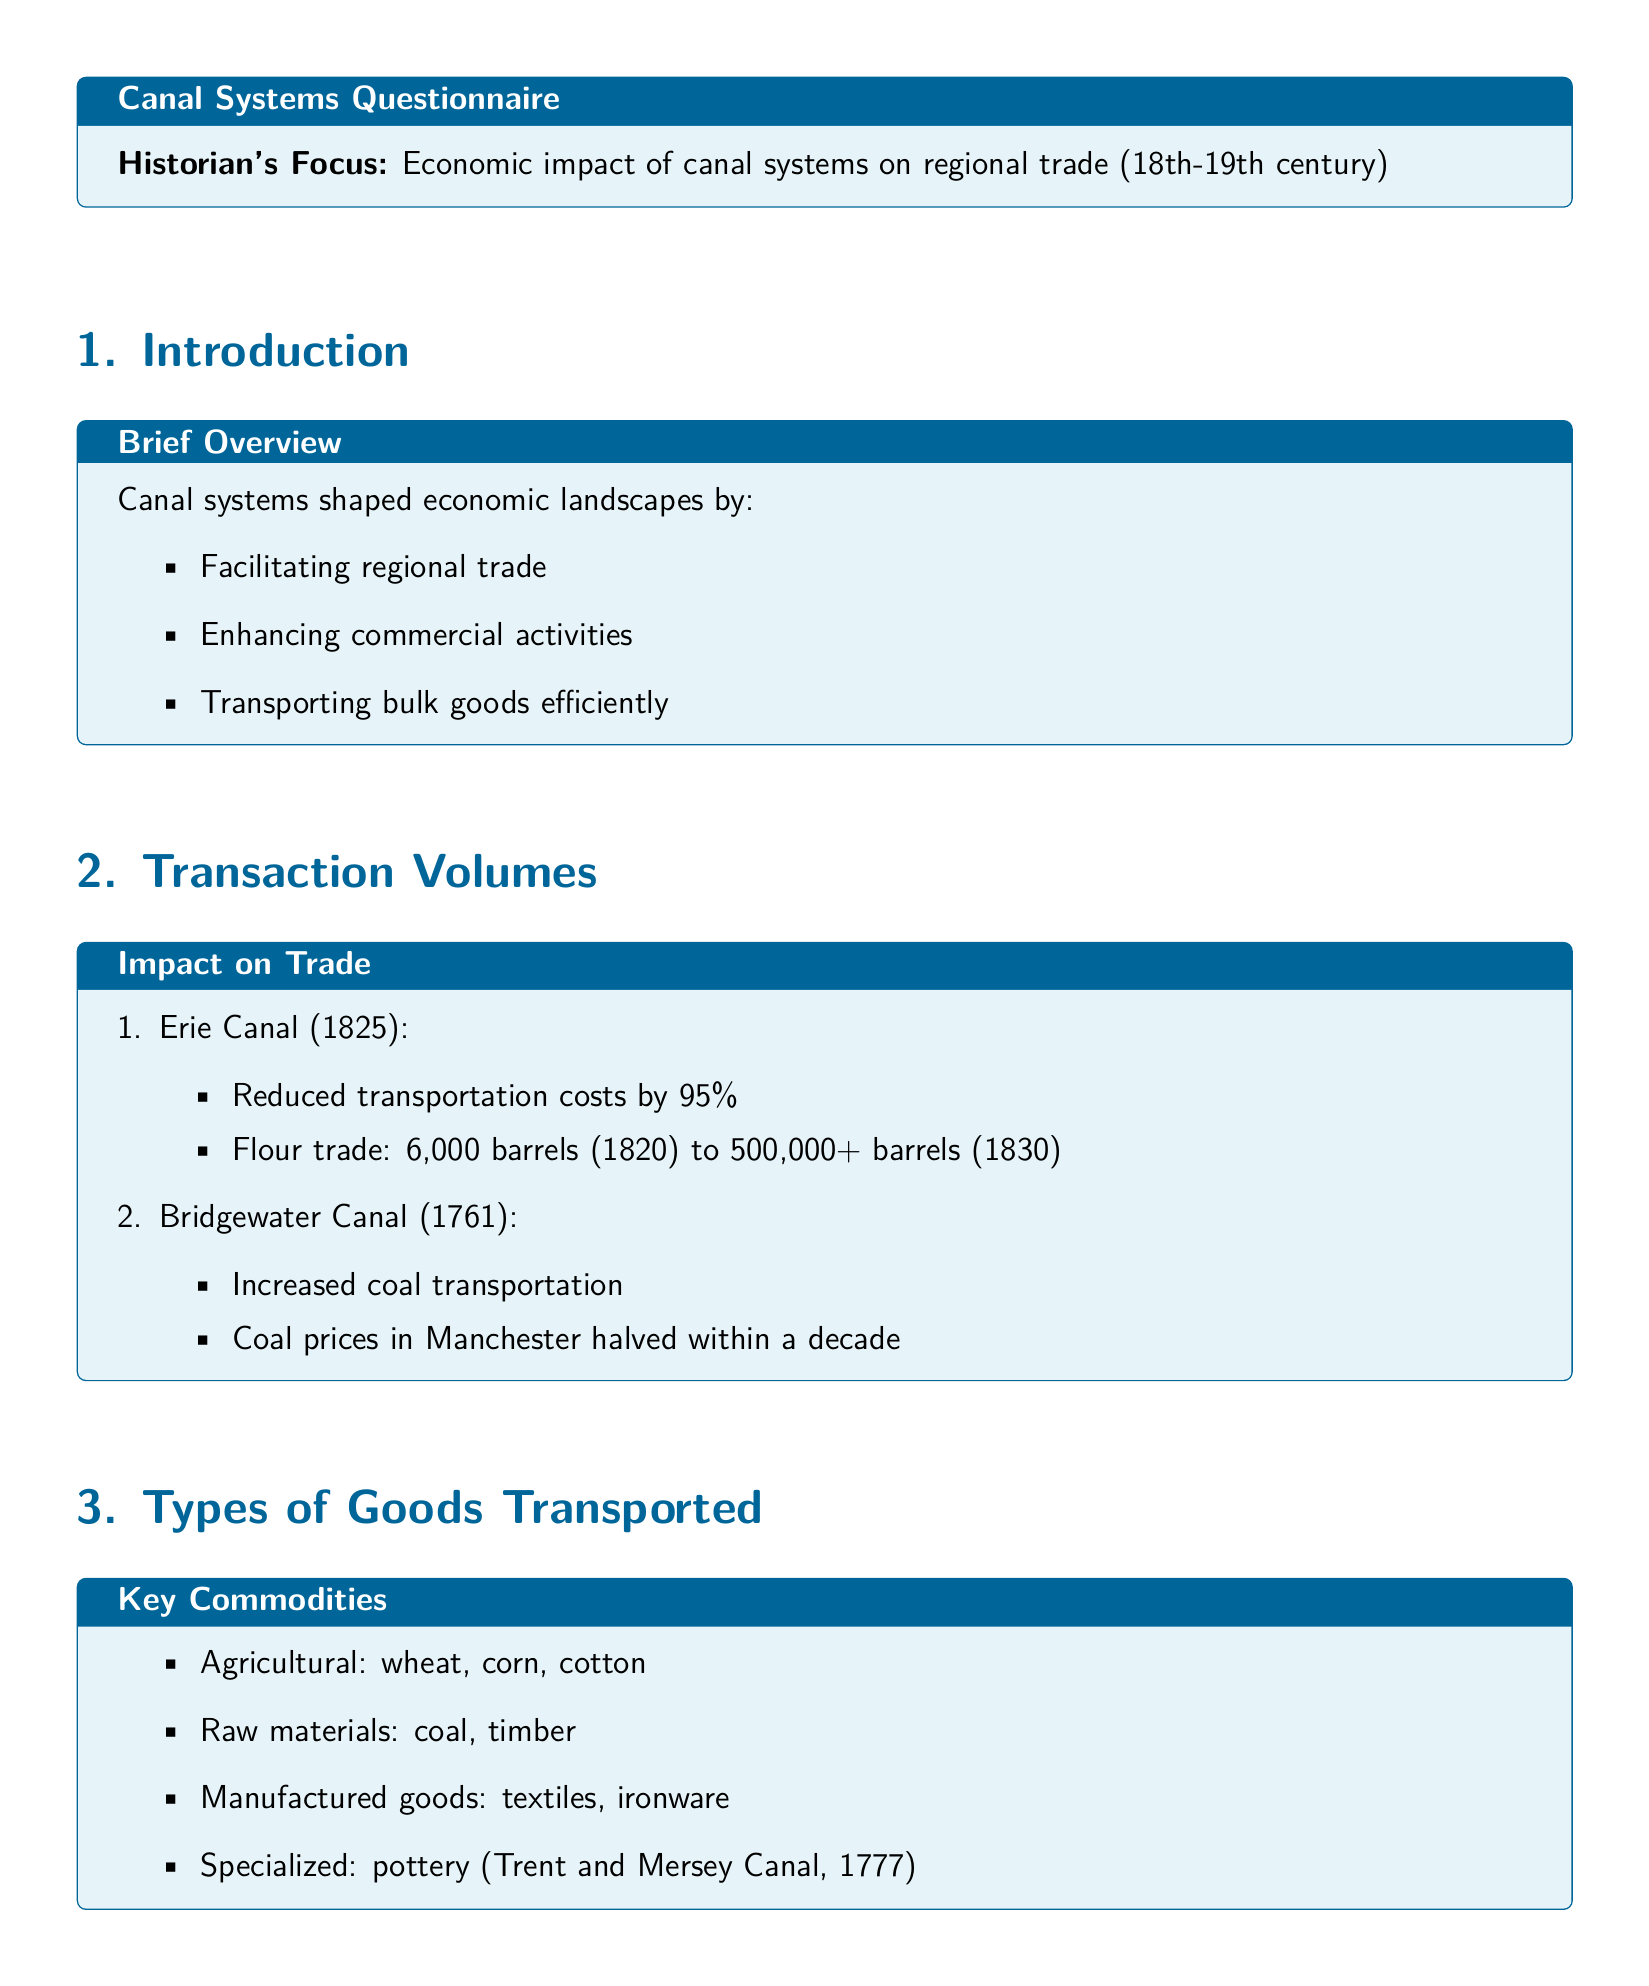What year was the Erie Canal completed? The document states that the Erie Canal was completed in 1825.
Answer: 1825 How much did transportation costs reduce by with the Erie Canal? The document indicates that transportation costs were reduced by 95% with the Erie Canal.
Answer: 95% What was the flour trade volume in barrels in 1830 after the Erie Canal's completion? The document mentions that the flour trade volume increased to over 500,000 barrels in 1830.
Answer: 500,000+ What types of agricultural goods were transported via canals? According to the document, the agricultural goods included wheat, corn, and cotton.
Answer: wheat, corn, cotton What key improvement did the Leeds and Liverpool Canal provide for goods transport? The document specifies that the Leeds and Liverpool Canal reduced goods transport time from weeks to days.
Answer: weeks to days Which canal was known for pottery transportation? The document states that the Trent and Mersey Canal, established in 1777, was known for pottery transportation.
Answer: Trent and Mersey Canal What economic effect did canal systems have on GDP? The document asserts that canal systems contributed to GDP growth as one of their outcomes.
Answer: GDP growth Which canal significantly halved coal prices in Manchester? The document indicates that the Bridgewater Canal was responsible for halving coal prices in Manchester.
Answer: Bridgewater Canal What was a major reliance for trade before canals? The document mentions that before canals, there was a reliance on horse-drawn wagons and natural waterways.
Answer: horse-drawn wagons and natural waterways 